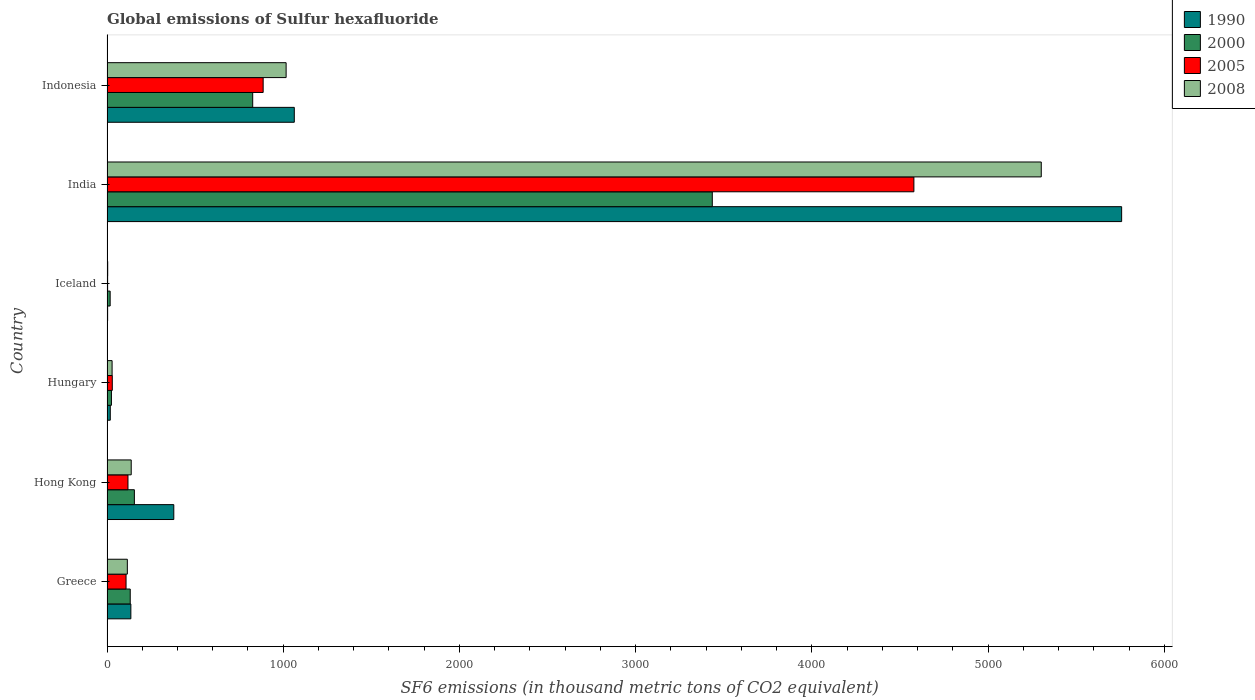How many groups of bars are there?
Offer a very short reply. 6. Are the number of bars per tick equal to the number of legend labels?
Make the answer very short. Yes. Are the number of bars on each tick of the Y-axis equal?
Offer a terse response. Yes. What is the label of the 5th group of bars from the top?
Give a very brief answer. Hong Kong. What is the global emissions of Sulfur hexafluoride in 2008 in Indonesia?
Offer a terse response. 1016.4. Across all countries, what is the maximum global emissions of Sulfur hexafluoride in 2005?
Offer a very short reply. 4578.7. What is the total global emissions of Sulfur hexafluoride in 2005 in the graph?
Your answer should be compact. 5725.4. What is the difference between the global emissions of Sulfur hexafluoride in 2008 in India and that in Indonesia?
Ensure brevity in your answer.  4285. What is the difference between the global emissions of Sulfur hexafluoride in 2008 in Greece and the global emissions of Sulfur hexafluoride in 1990 in Hong Kong?
Make the answer very short. -263.6. What is the average global emissions of Sulfur hexafluoride in 2005 per country?
Provide a short and direct response. 954.23. What is the difference between the global emissions of Sulfur hexafluoride in 1990 and global emissions of Sulfur hexafluoride in 2000 in Indonesia?
Your answer should be very brief. 236. In how many countries, is the global emissions of Sulfur hexafluoride in 2008 greater than 3200 thousand metric tons?
Provide a short and direct response. 1. What is the ratio of the global emissions of Sulfur hexafluoride in 2008 in Greece to that in Iceland?
Give a very brief answer. 28.85. What is the difference between the highest and the second highest global emissions of Sulfur hexafluoride in 2000?
Ensure brevity in your answer.  2607.9. What is the difference between the highest and the lowest global emissions of Sulfur hexafluoride in 2000?
Make the answer very short. 3416.8. In how many countries, is the global emissions of Sulfur hexafluoride in 2008 greater than the average global emissions of Sulfur hexafluoride in 2008 taken over all countries?
Your response must be concise. 1. Is the sum of the global emissions of Sulfur hexafluoride in 2008 in Iceland and India greater than the maximum global emissions of Sulfur hexafluoride in 2005 across all countries?
Make the answer very short. Yes. What does the 4th bar from the top in Hong Kong represents?
Provide a succinct answer. 1990. What does the 2nd bar from the bottom in Hungary represents?
Your answer should be very brief. 2000. Is it the case that in every country, the sum of the global emissions of Sulfur hexafluoride in 2008 and global emissions of Sulfur hexafluoride in 2000 is greater than the global emissions of Sulfur hexafluoride in 1990?
Your answer should be compact. No. Are all the bars in the graph horizontal?
Offer a terse response. Yes. What is the difference between two consecutive major ticks on the X-axis?
Make the answer very short. 1000. Where does the legend appear in the graph?
Your answer should be very brief. Top right. How are the legend labels stacked?
Keep it short and to the point. Vertical. What is the title of the graph?
Make the answer very short. Global emissions of Sulfur hexafluoride. What is the label or title of the X-axis?
Your response must be concise. SF6 emissions (in thousand metric tons of CO2 equivalent). What is the label or title of the Y-axis?
Your answer should be compact. Country. What is the SF6 emissions (in thousand metric tons of CO2 equivalent) of 1990 in Greece?
Offer a terse response. 135.4. What is the SF6 emissions (in thousand metric tons of CO2 equivalent) in 2000 in Greece?
Give a very brief answer. 131.8. What is the SF6 emissions (in thousand metric tons of CO2 equivalent) in 2005 in Greece?
Your answer should be very brief. 108.1. What is the SF6 emissions (in thousand metric tons of CO2 equivalent) of 2008 in Greece?
Ensure brevity in your answer.  115.4. What is the SF6 emissions (in thousand metric tons of CO2 equivalent) in 1990 in Hong Kong?
Offer a terse response. 379. What is the SF6 emissions (in thousand metric tons of CO2 equivalent) in 2000 in Hong Kong?
Offer a very short reply. 155.3. What is the SF6 emissions (in thousand metric tons of CO2 equivalent) in 2005 in Hong Kong?
Keep it short and to the point. 119. What is the SF6 emissions (in thousand metric tons of CO2 equivalent) of 2008 in Hong Kong?
Keep it short and to the point. 137.4. What is the SF6 emissions (in thousand metric tons of CO2 equivalent) in 1990 in Hungary?
Give a very brief answer. 18.6. What is the SF6 emissions (in thousand metric tons of CO2 equivalent) in 2000 in Hungary?
Your answer should be compact. 25.2. What is the SF6 emissions (in thousand metric tons of CO2 equivalent) in 2005 in Hungary?
Make the answer very short. 30. What is the SF6 emissions (in thousand metric tons of CO2 equivalent) in 2008 in Hungary?
Your response must be concise. 28.9. What is the SF6 emissions (in thousand metric tons of CO2 equivalent) in 1990 in Iceland?
Offer a terse response. 3.5. What is the SF6 emissions (in thousand metric tons of CO2 equivalent) in 1990 in India?
Your answer should be very brief. 5757.5. What is the SF6 emissions (in thousand metric tons of CO2 equivalent) of 2000 in India?
Provide a short and direct response. 3434.7. What is the SF6 emissions (in thousand metric tons of CO2 equivalent) in 2005 in India?
Your answer should be very brief. 4578.7. What is the SF6 emissions (in thousand metric tons of CO2 equivalent) of 2008 in India?
Provide a succinct answer. 5301.4. What is the SF6 emissions (in thousand metric tons of CO2 equivalent) in 1990 in Indonesia?
Offer a very short reply. 1062.8. What is the SF6 emissions (in thousand metric tons of CO2 equivalent) in 2000 in Indonesia?
Your answer should be compact. 826.8. What is the SF6 emissions (in thousand metric tons of CO2 equivalent) in 2005 in Indonesia?
Your answer should be very brief. 886.1. What is the SF6 emissions (in thousand metric tons of CO2 equivalent) in 2008 in Indonesia?
Offer a very short reply. 1016.4. Across all countries, what is the maximum SF6 emissions (in thousand metric tons of CO2 equivalent) of 1990?
Make the answer very short. 5757.5. Across all countries, what is the maximum SF6 emissions (in thousand metric tons of CO2 equivalent) in 2000?
Offer a very short reply. 3434.7. Across all countries, what is the maximum SF6 emissions (in thousand metric tons of CO2 equivalent) in 2005?
Provide a succinct answer. 4578.7. Across all countries, what is the maximum SF6 emissions (in thousand metric tons of CO2 equivalent) of 2008?
Your answer should be compact. 5301.4. Across all countries, what is the minimum SF6 emissions (in thousand metric tons of CO2 equivalent) of 2000?
Keep it short and to the point. 17.9. What is the total SF6 emissions (in thousand metric tons of CO2 equivalent) in 1990 in the graph?
Keep it short and to the point. 7356.8. What is the total SF6 emissions (in thousand metric tons of CO2 equivalent) in 2000 in the graph?
Ensure brevity in your answer.  4591.7. What is the total SF6 emissions (in thousand metric tons of CO2 equivalent) in 2005 in the graph?
Provide a succinct answer. 5725.4. What is the total SF6 emissions (in thousand metric tons of CO2 equivalent) of 2008 in the graph?
Your response must be concise. 6603.5. What is the difference between the SF6 emissions (in thousand metric tons of CO2 equivalent) of 1990 in Greece and that in Hong Kong?
Make the answer very short. -243.6. What is the difference between the SF6 emissions (in thousand metric tons of CO2 equivalent) in 2000 in Greece and that in Hong Kong?
Provide a succinct answer. -23.5. What is the difference between the SF6 emissions (in thousand metric tons of CO2 equivalent) of 1990 in Greece and that in Hungary?
Offer a very short reply. 116.8. What is the difference between the SF6 emissions (in thousand metric tons of CO2 equivalent) in 2000 in Greece and that in Hungary?
Provide a succinct answer. 106.6. What is the difference between the SF6 emissions (in thousand metric tons of CO2 equivalent) of 2005 in Greece and that in Hungary?
Provide a short and direct response. 78.1. What is the difference between the SF6 emissions (in thousand metric tons of CO2 equivalent) in 2008 in Greece and that in Hungary?
Provide a short and direct response. 86.5. What is the difference between the SF6 emissions (in thousand metric tons of CO2 equivalent) in 1990 in Greece and that in Iceland?
Offer a very short reply. 131.9. What is the difference between the SF6 emissions (in thousand metric tons of CO2 equivalent) in 2000 in Greece and that in Iceland?
Give a very brief answer. 113.9. What is the difference between the SF6 emissions (in thousand metric tons of CO2 equivalent) in 2005 in Greece and that in Iceland?
Make the answer very short. 104.6. What is the difference between the SF6 emissions (in thousand metric tons of CO2 equivalent) in 2008 in Greece and that in Iceland?
Make the answer very short. 111.4. What is the difference between the SF6 emissions (in thousand metric tons of CO2 equivalent) of 1990 in Greece and that in India?
Your answer should be very brief. -5622.1. What is the difference between the SF6 emissions (in thousand metric tons of CO2 equivalent) of 2000 in Greece and that in India?
Ensure brevity in your answer.  -3302.9. What is the difference between the SF6 emissions (in thousand metric tons of CO2 equivalent) in 2005 in Greece and that in India?
Your answer should be compact. -4470.6. What is the difference between the SF6 emissions (in thousand metric tons of CO2 equivalent) in 2008 in Greece and that in India?
Your response must be concise. -5186. What is the difference between the SF6 emissions (in thousand metric tons of CO2 equivalent) in 1990 in Greece and that in Indonesia?
Keep it short and to the point. -927.4. What is the difference between the SF6 emissions (in thousand metric tons of CO2 equivalent) in 2000 in Greece and that in Indonesia?
Your answer should be very brief. -695. What is the difference between the SF6 emissions (in thousand metric tons of CO2 equivalent) in 2005 in Greece and that in Indonesia?
Make the answer very short. -778. What is the difference between the SF6 emissions (in thousand metric tons of CO2 equivalent) of 2008 in Greece and that in Indonesia?
Provide a short and direct response. -901. What is the difference between the SF6 emissions (in thousand metric tons of CO2 equivalent) of 1990 in Hong Kong and that in Hungary?
Offer a very short reply. 360.4. What is the difference between the SF6 emissions (in thousand metric tons of CO2 equivalent) in 2000 in Hong Kong and that in Hungary?
Provide a succinct answer. 130.1. What is the difference between the SF6 emissions (in thousand metric tons of CO2 equivalent) in 2005 in Hong Kong and that in Hungary?
Ensure brevity in your answer.  89. What is the difference between the SF6 emissions (in thousand metric tons of CO2 equivalent) in 2008 in Hong Kong and that in Hungary?
Provide a succinct answer. 108.5. What is the difference between the SF6 emissions (in thousand metric tons of CO2 equivalent) of 1990 in Hong Kong and that in Iceland?
Provide a short and direct response. 375.5. What is the difference between the SF6 emissions (in thousand metric tons of CO2 equivalent) in 2000 in Hong Kong and that in Iceland?
Give a very brief answer. 137.4. What is the difference between the SF6 emissions (in thousand metric tons of CO2 equivalent) in 2005 in Hong Kong and that in Iceland?
Provide a succinct answer. 115.5. What is the difference between the SF6 emissions (in thousand metric tons of CO2 equivalent) of 2008 in Hong Kong and that in Iceland?
Ensure brevity in your answer.  133.4. What is the difference between the SF6 emissions (in thousand metric tons of CO2 equivalent) in 1990 in Hong Kong and that in India?
Keep it short and to the point. -5378.5. What is the difference between the SF6 emissions (in thousand metric tons of CO2 equivalent) of 2000 in Hong Kong and that in India?
Offer a very short reply. -3279.4. What is the difference between the SF6 emissions (in thousand metric tons of CO2 equivalent) of 2005 in Hong Kong and that in India?
Provide a succinct answer. -4459.7. What is the difference between the SF6 emissions (in thousand metric tons of CO2 equivalent) of 2008 in Hong Kong and that in India?
Your response must be concise. -5164. What is the difference between the SF6 emissions (in thousand metric tons of CO2 equivalent) of 1990 in Hong Kong and that in Indonesia?
Keep it short and to the point. -683.8. What is the difference between the SF6 emissions (in thousand metric tons of CO2 equivalent) of 2000 in Hong Kong and that in Indonesia?
Your response must be concise. -671.5. What is the difference between the SF6 emissions (in thousand metric tons of CO2 equivalent) of 2005 in Hong Kong and that in Indonesia?
Offer a terse response. -767.1. What is the difference between the SF6 emissions (in thousand metric tons of CO2 equivalent) of 2008 in Hong Kong and that in Indonesia?
Keep it short and to the point. -879. What is the difference between the SF6 emissions (in thousand metric tons of CO2 equivalent) in 1990 in Hungary and that in Iceland?
Provide a short and direct response. 15.1. What is the difference between the SF6 emissions (in thousand metric tons of CO2 equivalent) in 2008 in Hungary and that in Iceland?
Provide a succinct answer. 24.9. What is the difference between the SF6 emissions (in thousand metric tons of CO2 equivalent) of 1990 in Hungary and that in India?
Make the answer very short. -5738.9. What is the difference between the SF6 emissions (in thousand metric tons of CO2 equivalent) of 2000 in Hungary and that in India?
Your response must be concise. -3409.5. What is the difference between the SF6 emissions (in thousand metric tons of CO2 equivalent) of 2005 in Hungary and that in India?
Offer a terse response. -4548.7. What is the difference between the SF6 emissions (in thousand metric tons of CO2 equivalent) of 2008 in Hungary and that in India?
Keep it short and to the point. -5272.5. What is the difference between the SF6 emissions (in thousand metric tons of CO2 equivalent) of 1990 in Hungary and that in Indonesia?
Your response must be concise. -1044.2. What is the difference between the SF6 emissions (in thousand metric tons of CO2 equivalent) in 2000 in Hungary and that in Indonesia?
Keep it short and to the point. -801.6. What is the difference between the SF6 emissions (in thousand metric tons of CO2 equivalent) of 2005 in Hungary and that in Indonesia?
Your response must be concise. -856.1. What is the difference between the SF6 emissions (in thousand metric tons of CO2 equivalent) of 2008 in Hungary and that in Indonesia?
Your response must be concise. -987.5. What is the difference between the SF6 emissions (in thousand metric tons of CO2 equivalent) of 1990 in Iceland and that in India?
Your response must be concise. -5754. What is the difference between the SF6 emissions (in thousand metric tons of CO2 equivalent) in 2000 in Iceland and that in India?
Your answer should be compact. -3416.8. What is the difference between the SF6 emissions (in thousand metric tons of CO2 equivalent) in 2005 in Iceland and that in India?
Give a very brief answer. -4575.2. What is the difference between the SF6 emissions (in thousand metric tons of CO2 equivalent) of 2008 in Iceland and that in India?
Offer a terse response. -5297.4. What is the difference between the SF6 emissions (in thousand metric tons of CO2 equivalent) of 1990 in Iceland and that in Indonesia?
Your answer should be compact. -1059.3. What is the difference between the SF6 emissions (in thousand metric tons of CO2 equivalent) of 2000 in Iceland and that in Indonesia?
Provide a succinct answer. -808.9. What is the difference between the SF6 emissions (in thousand metric tons of CO2 equivalent) of 2005 in Iceland and that in Indonesia?
Your answer should be very brief. -882.6. What is the difference between the SF6 emissions (in thousand metric tons of CO2 equivalent) of 2008 in Iceland and that in Indonesia?
Offer a terse response. -1012.4. What is the difference between the SF6 emissions (in thousand metric tons of CO2 equivalent) of 1990 in India and that in Indonesia?
Ensure brevity in your answer.  4694.7. What is the difference between the SF6 emissions (in thousand metric tons of CO2 equivalent) of 2000 in India and that in Indonesia?
Make the answer very short. 2607.9. What is the difference between the SF6 emissions (in thousand metric tons of CO2 equivalent) of 2005 in India and that in Indonesia?
Offer a very short reply. 3692.6. What is the difference between the SF6 emissions (in thousand metric tons of CO2 equivalent) in 2008 in India and that in Indonesia?
Give a very brief answer. 4285. What is the difference between the SF6 emissions (in thousand metric tons of CO2 equivalent) of 1990 in Greece and the SF6 emissions (in thousand metric tons of CO2 equivalent) of 2000 in Hong Kong?
Provide a short and direct response. -19.9. What is the difference between the SF6 emissions (in thousand metric tons of CO2 equivalent) of 2005 in Greece and the SF6 emissions (in thousand metric tons of CO2 equivalent) of 2008 in Hong Kong?
Give a very brief answer. -29.3. What is the difference between the SF6 emissions (in thousand metric tons of CO2 equivalent) of 1990 in Greece and the SF6 emissions (in thousand metric tons of CO2 equivalent) of 2000 in Hungary?
Provide a succinct answer. 110.2. What is the difference between the SF6 emissions (in thousand metric tons of CO2 equivalent) in 1990 in Greece and the SF6 emissions (in thousand metric tons of CO2 equivalent) in 2005 in Hungary?
Provide a succinct answer. 105.4. What is the difference between the SF6 emissions (in thousand metric tons of CO2 equivalent) of 1990 in Greece and the SF6 emissions (in thousand metric tons of CO2 equivalent) of 2008 in Hungary?
Your answer should be very brief. 106.5. What is the difference between the SF6 emissions (in thousand metric tons of CO2 equivalent) in 2000 in Greece and the SF6 emissions (in thousand metric tons of CO2 equivalent) in 2005 in Hungary?
Offer a terse response. 101.8. What is the difference between the SF6 emissions (in thousand metric tons of CO2 equivalent) in 2000 in Greece and the SF6 emissions (in thousand metric tons of CO2 equivalent) in 2008 in Hungary?
Offer a terse response. 102.9. What is the difference between the SF6 emissions (in thousand metric tons of CO2 equivalent) of 2005 in Greece and the SF6 emissions (in thousand metric tons of CO2 equivalent) of 2008 in Hungary?
Provide a succinct answer. 79.2. What is the difference between the SF6 emissions (in thousand metric tons of CO2 equivalent) of 1990 in Greece and the SF6 emissions (in thousand metric tons of CO2 equivalent) of 2000 in Iceland?
Your response must be concise. 117.5. What is the difference between the SF6 emissions (in thousand metric tons of CO2 equivalent) of 1990 in Greece and the SF6 emissions (in thousand metric tons of CO2 equivalent) of 2005 in Iceland?
Ensure brevity in your answer.  131.9. What is the difference between the SF6 emissions (in thousand metric tons of CO2 equivalent) of 1990 in Greece and the SF6 emissions (in thousand metric tons of CO2 equivalent) of 2008 in Iceland?
Your answer should be very brief. 131.4. What is the difference between the SF6 emissions (in thousand metric tons of CO2 equivalent) in 2000 in Greece and the SF6 emissions (in thousand metric tons of CO2 equivalent) in 2005 in Iceland?
Provide a succinct answer. 128.3. What is the difference between the SF6 emissions (in thousand metric tons of CO2 equivalent) of 2000 in Greece and the SF6 emissions (in thousand metric tons of CO2 equivalent) of 2008 in Iceland?
Make the answer very short. 127.8. What is the difference between the SF6 emissions (in thousand metric tons of CO2 equivalent) of 2005 in Greece and the SF6 emissions (in thousand metric tons of CO2 equivalent) of 2008 in Iceland?
Provide a short and direct response. 104.1. What is the difference between the SF6 emissions (in thousand metric tons of CO2 equivalent) of 1990 in Greece and the SF6 emissions (in thousand metric tons of CO2 equivalent) of 2000 in India?
Your answer should be compact. -3299.3. What is the difference between the SF6 emissions (in thousand metric tons of CO2 equivalent) in 1990 in Greece and the SF6 emissions (in thousand metric tons of CO2 equivalent) in 2005 in India?
Offer a very short reply. -4443.3. What is the difference between the SF6 emissions (in thousand metric tons of CO2 equivalent) of 1990 in Greece and the SF6 emissions (in thousand metric tons of CO2 equivalent) of 2008 in India?
Your answer should be compact. -5166. What is the difference between the SF6 emissions (in thousand metric tons of CO2 equivalent) in 2000 in Greece and the SF6 emissions (in thousand metric tons of CO2 equivalent) in 2005 in India?
Offer a terse response. -4446.9. What is the difference between the SF6 emissions (in thousand metric tons of CO2 equivalent) in 2000 in Greece and the SF6 emissions (in thousand metric tons of CO2 equivalent) in 2008 in India?
Your response must be concise. -5169.6. What is the difference between the SF6 emissions (in thousand metric tons of CO2 equivalent) in 2005 in Greece and the SF6 emissions (in thousand metric tons of CO2 equivalent) in 2008 in India?
Make the answer very short. -5193.3. What is the difference between the SF6 emissions (in thousand metric tons of CO2 equivalent) of 1990 in Greece and the SF6 emissions (in thousand metric tons of CO2 equivalent) of 2000 in Indonesia?
Provide a succinct answer. -691.4. What is the difference between the SF6 emissions (in thousand metric tons of CO2 equivalent) in 1990 in Greece and the SF6 emissions (in thousand metric tons of CO2 equivalent) in 2005 in Indonesia?
Your answer should be compact. -750.7. What is the difference between the SF6 emissions (in thousand metric tons of CO2 equivalent) of 1990 in Greece and the SF6 emissions (in thousand metric tons of CO2 equivalent) of 2008 in Indonesia?
Offer a terse response. -881. What is the difference between the SF6 emissions (in thousand metric tons of CO2 equivalent) in 2000 in Greece and the SF6 emissions (in thousand metric tons of CO2 equivalent) in 2005 in Indonesia?
Provide a succinct answer. -754.3. What is the difference between the SF6 emissions (in thousand metric tons of CO2 equivalent) in 2000 in Greece and the SF6 emissions (in thousand metric tons of CO2 equivalent) in 2008 in Indonesia?
Make the answer very short. -884.6. What is the difference between the SF6 emissions (in thousand metric tons of CO2 equivalent) in 2005 in Greece and the SF6 emissions (in thousand metric tons of CO2 equivalent) in 2008 in Indonesia?
Offer a terse response. -908.3. What is the difference between the SF6 emissions (in thousand metric tons of CO2 equivalent) of 1990 in Hong Kong and the SF6 emissions (in thousand metric tons of CO2 equivalent) of 2000 in Hungary?
Provide a short and direct response. 353.8. What is the difference between the SF6 emissions (in thousand metric tons of CO2 equivalent) in 1990 in Hong Kong and the SF6 emissions (in thousand metric tons of CO2 equivalent) in 2005 in Hungary?
Provide a short and direct response. 349. What is the difference between the SF6 emissions (in thousand metric tons of CO2 equivalent) of 1990 in Hong Kong and the SF6 emissions (in thousand metric tons of CO2 equivalent) of 2008 in Hungary?
Your answer should be compact. 350.1. What is the difference between the SF6 emissions (in thousand metric tons of CO2 equivalent) of 2000 in Hong Kong and the SF6 emissions (in thousand metric tons of CO2 equivalent) of 2005 in Hungary?
Provide a short and direct response. 125.3. What is the difference between the SF6 emissions (in thousand metric tons of CO2 equivalent) in 2000 in Hong Kong and the SF6 emissions (in thousand metric tons of CO2 equivalent) in 2008 in Hungary?
Keep it short and to the point. 126.4. What is the difference between the SF6 emissions (in thousand metric tons of CO2 equivalent) of 2005 in Hong Kong and the SF6 emissions (in thousand metric tons of CO2 equivalent) of 2008 in Hungary?
Make the answer very short. 90.1. What is the difference between the SF6 emissions (in thousand metric tons of CO2 equivalent) in 1990 in Hong Kong and the SF6 emissions (in thousand metric tons of CO2 equivalent) in 2000 in Iceland?
Offer a very short reply. 361.1. What is the difference between the SF6 emissions (in thousand metric tons of CO2 equivalent) in 1990 in Hong Kong and the SF6 emissions (in thousand metric tons of CO2 equivalent) in 2005 in Iceland?
Your response must be concise. 375.5. What is the difference between the SF6 emissions (in thousand metric tons of CO2 equivalent) in 1990 in Hong Kong and the SF6 emissions (in thousand metric tons of CO2 equivalent) in 2008 in Iceland?
Offer a very short reply. 375. What is the difference between the SF6 emissions (in thousand metric tons of CO2 equivalent) of 2000 in Hong Kong and the SF6 emissions (in thousand metric tons of CO2 equivalent) of 2005 in Iceland?
Give a very brief answer. 151.8. What is the difference between the SF6 emissions (in thousand metric tons of CO2 equivalent) of 2000 in Hong Kong and the SF6 emissions (in thousand metric tons of CO2 equivalent) of 2008 in Iceland?
Your answer should be compact. 151.3. What is the difference between the SF6 emissions (in thousand metric tons of CO2 equivalent) of 2005 in Hong Kong and the SF6 emissions (in thousand metric tons of CO2 equivalent) of 2008 in Iceland?
Give a very brief answer. 115. What is the difference between the SF6 emissions (in thousand metric tons of CO2 equivalent) in 1990 in Hong Kong and the SF6 emissions (in thousand metric tons of CO2 equivalent) in 2000 in India?
Keep it short and to the point. -3055.7. What is the difference between the SF6 emissions (in thousand metric tons of CO2 equivalent) in 1990 in Hong Kong and the SF6 emissions (in thousand metric tons of CO2 equivalent) in 2005 in India?
Give a very brief answer. -4199.7. What is the difference between the SF6 emissions (in thousand metric tons of CO2 equivalent) in 1990 in Hong Kong and the SF6 emissions (in thousand metric tons of CO2 equivalent) in 2008 in India?
Give a very brief answer. -4922.4. What is the difference between the SF6 emissions (in thousand metric tons of CO2 equivalent) in 2000 in Hong Kong and the SF6 emissions (in thousand metric tons of CO2 equivalent) in 2005 in India?
Give a very brief answer. -4423.4. What is the difference between the SF6 emissions (in thousand metric tons of CO2 equivalent) of 2000 in Hong Kong and the SF6 emissions (in thousand metric tons of CO2 equivalent) of 2008 in India?
Your answer should be compact. -5146.1. What is the difference between the SF6 emissions (in thousand metric tons of CO2 equivalent) of 2005 in Hong Kong and the SF6 emissions (in thousand metric tons of CO2 equivalent) of 2008 in India?
Your answer should be very brief. -5182.4. What is the difference between the SF6 emissions (in thousand metric tons of CO2 equivalent) of 1990 in Hong Kong and the SF6 emissions (in thousand metric tons of CO2 equivalent) of 2000 in Indonesia?
Make the answer very short. -447.8. What is the difference between the SF6 emissions (in thousand metric tons of CO2 equivalent) of 1990 in Hong Kong and the SF6 emissions (in thousand metric tons of CO2 equivalent) of 2005 in Indonesia?
Offer a terse response. -507.1. What is the difference between the SF6 emissions (in thousand metric tons of CO2 equivalent) of 1990 in Hong Kong and the SF6 emissions (in thousand metric tons of CO2 equivalent) of 2008 in Indonesia?
Keep it short and to the point. -637.4. What is the difference between the SF6 emissions (in thousand metric tons of CO2 equivalent) of 2000 in Hong Kong and the SF6 emissions (in thousand metric tons of CO2 equivalent) of 2005 in Indonesia?
Make the answer very short. -730.8. What is the difference between the SF6 emissions (in thousand metric tons of CO2 equivalent) of 2000 in Hong Kong and the SF6 emissions (in thousand metric tons of CO2 equivalent) of 2008 in Indonesia?
Offer a very short reply. -861.1. What is the difference between the SF6 emissions (in thousand metric tons of CO2 equivalent) of 2005 in Hong Kong and the SF6 emissions (in thousand metric tons of CO2 equivalent) of 2008 in Indonesia?
Keep it short and to the point. -897.4. What is the difference between the SF6 emissions (in thousand metric tons of CO2 equivalent) of 1990 in Hungary and the SF6 emissions (in thousand metric tons of CO2 equivalent) of 2005 in Iceland?
Your response must be concise. 15.1. What is the difference between the SF6 emissions (in thousand metric tons of CO2 equivalent) in 2000 in Hungary and the SF6 emissions (in thousand metric tons of CO2 equivalent) in 2005 in Iceland?
Your response must be concise. 21.7. What is the difference between the SF6 emissions (in thousand metric tons of CO2 equivalent) in 2000 in Hungary and the SF6 emissions (in thousand metric tons of CO2 equivalent) in 2008 in Iceland?
Ensure brevity in your answer.  21.2. What is the difference between the SF6 emissions (in thousand metric tons of CO2 equivalent) of 1990 in Hungary and the SF6 emissions (in thousand metric tons of CO2 equivalent) of 2000 in India?
Offer a terse response. -3416.1. What is the difference between the SF6 emissions (in thousand metric tons of CO2 equivalent) in 1990 in Hungary and the SF6 emissions (in thousand metric tons of CO2 equivalent) in 2005 in India?
Offer a terse response. -4560.1. What is the difference between the SF6 emissions (in thousand metric tons of CO2 equivalent) of 1990 in Hungary and the SF6 emissions (in thousand metric tons of CO2 equivalent) of 2008 in India?
Keep it short and to the point. -5282.8. What is the difference between the SF6 emissions (in thousand metric tons of CO2 equivalent) of 2000 in Hungary and the SF6 emissions (in thousand metric tons of CO2 equivalent) of 2005 in India?
Offer a very short reply. -4553.5. What is the difference between the SF6 emissions (in thousand metric tons of CO2 equivalent) of 2000 in Hungary and the SF6 emissions (in thousand metric tons of CO2 equivalent) of 2008 in India?
Offer a terse response. -5276.2. What is the difference between the SF6 emissions (in thousand metric tons of CO2 equivalent) in 2005 in Hungary and the SF6 emissions (in thousand metric tons of CO2 equivalent) in 2008 in India?
Make the answer very short. -5271.4. What is the difference between the SF6 emissions (in thousand metric tons of CO2 equivalent) of 1990 in Hungary and the SF6 emissions (in thousand metric tons of CO2 equivalent) of 2000 in Indonesia?
Your response must be concise. -808.2. What is the difference between the SF6 emissions (in thousand metric tons of CO2 equivalent) of 1990 in Hungary and the SF6 emissions (in thousand metric tons of CO2 equivalent) of 2005 in Indonesia?
Keep it short and to the point. -867.5. What is the difference between the SF6 emissions (in thousand metric tons of CO2 equivalent) of 1990 in Hungary and the SF6 emissions (in thousand metric tons of CO2 equivalent) of 2008 in Indonesia?
Provide a short and direct response. -997.8. What is the difference between the SF6 emissions (in thousand metric tons of CO2 equivalent) of 2000 in Hungary and the SF6 emissions (in thousand metric tons of CO2 equivalent) of 2005 in Indonesia?
Keep it short and to the point. -860.9. What is the difference between the SF6 emissions (in thousand metric tons of CO2 equivalent) in 2000 in Hungary and the SF6 emissions (in thousand metric tons of CO2 equivalent) in 2008 in Indonesia?
Your answer should be very brief. -991.2. What is the difference between the SF6 emissions (in thousand metric tons of CO2 equivalent) in 2005 in Hungary and the SF6 emissions (in thousand metric tons of CO2 equivalent) in 2008 in Indonesia?
Give a very brief answer. -986.4. What is the difference between the SF6 emissions (in thousand metric tons of CO2 equivalent) of 1990 in Iceland and the SF6 emissions (in thousand metric tons of CO2 equivalent) of 2000 in India?
Provide a short and direct response. -3431.2. What is the difference between the SF6 emissions (in thousand metric tons of CO2 equivalent) in 1990 in Iceland and the SF6 emissions (in thousand metric tons of CO2 equivalent) in 2005 in India?
Your response must be concise. -4575.2. What is the difference between the SF6 emissions (in thousand metric tons of CO2 equivalent) in 1990 in Iceland and the SF6 emissions (in thousand metric tons of CO2 equivalent) in 2008 in India?
Provide a succinct answer. -5297.9. What is the difference between the SF6 emissions (in thousand metric tons of CO2 equivalent) in 2000 in Iceland and the SF6 emissions (in thousand metric tons of CO2 equivalent) in 2005 in India?
Offer a very short reply. -4560.8. What is the difference between the SF6 emissions (in thousand metric tons of CO2 equivalent) in 2000 in Iceland and the SF6 emissions (in thousand metric tons of CO2 equivalent) in 2008 in India?
Your response must be concise. -5283.5. What is the difference between the SF6 emissions (in thousand metric tons of CO2 equivalent) of 2005 in Iceland and the SF6 emissions (in thousand metric tons of CO2 equivalent) of 2008 in India?
Ensure brevity in your answer.  -5297.9. What is the difference between the SF6 emissions (in thousand metric tons of CO2 equivalent) of 1990 in Iceland and the SF6 emissions (in thousand metric tons of CO2 equivalent) of 2000 in Indonesia?
Make the answer very short. -823.3. What is the difference between the SF6 emissions (in thousand metric tons of CO2 equivalent) of 1990 in Iceland and the SF6 emissions (in thousand metric tons of CO2 equivalent) of 2005 in Indonesia?
Your answer should be very brief. -882.6. What is the difference between the SF6 emissions (in thousand metric tons of CO2 equivalent) of 1990 in Iceland and the SF6 emissions (in thousand metric tons of CO2 equivalent) of 2008 in Indonesia?
Keep it short and to the point. -1012.9. What is the difference between the SF6 emissions (in thousand metric tons of CO2 equivalent) in 2000 in Iceland and the SF6 emissions (in thousand metric tons of CO2 equivalent) in 2005 in Indonesia?
Keep it short and to the point. -868.2. What is the difference between the SF6 emissions (in thousand metric tons of CO2 equivalent) of 2000 in Iceland and the SF6 emissions (in thousand metric tons of CO2 equivalent) of 2008 in Indonesia?
Offer a terse response. -998.5. What is the difference between the SF6 emissions (in thousand metric tons of CO2 equivalent) in 2005 in Iceland and the SF6 emissions (in thousand metric tons of CO2 equivalent) in 2008 in Indonesia?
Keep it short and to the point. -1012.9. What is the difference between the SF6 emissions (in thousand metric tons of CO2 equivalent) in 1990 in India and the SF6 emissions (in thousand metric tons of CO2 equivalent) in 2000 in Indonesia?
Give a very brief answer. 4930.7. What is the difference between the SF6 emissions (in thousand metric tons of CO2 equivalent) in 1990 in India and the SF6 emissions (in thousand metric tons of CO2 equivalent) in 2005 in Indonesia?
Offer a terse response. 4871.4. What is the difference between the SF6 emissions (in thousand metric tons of CO2 equivalent) in 1990 in India and the SF6 emissions (in thousand metric tons of CO2 equivalent) in 2008 in Indonesia?
Give a very brief answer. 4741.1. What is the difference between the SF6 emissions (in thousand metric tons of CO2 equivalent) in 2000 in India and the SF6 emissions (in thousand metric tons of CO2 equivalent) in 2005 in Indonesia?
Offer a terse response. 2548.6. What is the difference between the SF6 emissions (in thousand metric tons of CO2 equivalent) of 2000 in India and the SF6 emissions (in thousand metric tons of CO2 equivalent) of 2008 in Indonesia?
Your response must be concise. 2418.3. What is the difference between the SF6 emissions (in thousand metric tons of CO2 equivalent) in 2005 in India and the SF6 emissions (in thousand metric tons of CO2 equivalent) in 2008 in Indonesia?
Ensure brevity in your answer.  3562.3. What is the average SF6 emissions (in thousand metric tons of CO2 equivalent) of 1990 per country?
Offer a very short reply. 1226.13. What is the average SF6 emissions (in thousand metric tons of CO2 equivalent) in 2000 per country?
Your answer should be compact. 765.28. What is the average SF6 emissions (in thousand metric tons of CO2 equivalent) of 2005 per country?
Offer a terse response. 954.23. What is the average SF6 emissions (in thousand metric tons of CO2 equivalent) in 2008 per country?
Your answer should be very brief. 1100.58. What is the difference between the SF6 emissions (in thousand metric tons of CO2 equivalent) in 1990 and SF6 emissions (in thousand metric tons of CO2 equivalent) in 2005 in Greece?
Offer a very short reply. 27.3. What is the difference between the SF6 emissions (in thousand metric tons of CO2 equivalent) in 1990 and SF6 emissions (in thousand metric tons of CO2 equivalent) in 2008 in Greece?
Provide a succinct answer. 20. What is the difference between the SF6 emissions (in thousand metric tons of CO2 equivalent) in 2000 and SF6 emissions (in thousand metric tons of CO2 equivalent) in 2005 in Greece?
Keep it short and to the point. 23.7. What is the difference between the SF6 emissions (in thousand metric tons of CO2 equivalent) in 2005 and SF6 emissions (in thousand metric tons of CO2 equivalent) in 2008 in Greece?
Make the answer very short. -7.3. What is the difference between the SF6 emissions (in thousand metric tons of CO2 equivalent) of 1990 and SF6 emissions (in thousand metric tons of CO2 equivalent) of 2000 in Hong Kong?
Provide a short and direct response. 223.7. What is the difference between the SF6 emissions (in thousand metric tons of CO2 equivalent) in 1990 and SF6 emissions (in thousand metric tons of CO2 equivalent) in 2005 in Hong Kong?
Provide a succinct answer. 260. What is the difference between the SF6 emissions (in thousand metric tons of CO2 equivalent) in 1990 and SF6 emissions (in thousand metric tons of CO2 equivalent) in 2008 in Hong Kong?
Provide a short and direct response. 241.6. What is the difference between the SF6 emissions (in thousand metric tons of CO2 equivalent) in 2000 and SF6 emissions (in thousand metric tons of CO2 equivalent) in 2005 in Hong Kong?
Your answer should be very brief. 36.3. What is the difference between the SF6 emissions (in thousand metric tons of CO2 equivalent) of 2000 and SF6 emissions (in thousand metric tons of CO2 equivalent) of 2008 in Hong Kong?
Your answer should be compact. 17.9. What is the difference between the SF6 emissions (in thousand metric tons of CO2 equivalent) in 2005 and SF6 emissions (in thousand metric tons of CO2 equivalent) in 2008 in Hong Kong?
Provide a succinct answer. -18.4. What is the difference between the SF6 emissions (in thousand metric tons of CO2 equivalent) in 2000 and SF6 emissions (in thousand metric tons of CO2 equivalent) in 2005 in Hungary?
Your response must be concise. -4.8. What is the difference between the SF6 emissions (in thousand metric tons of CO2 equivalent) in 2000 and SF6 emissions (in thousand metric tons of CO2 equivalent) in 2008 in Hungary?
Your answer should be very brief. -3.7. What is the difference between the SF6 emissions (in thousand metric tons of CO2 equivalent) of 2005 and SF6 emissions (in thousand metric tons of CO2 equivalent) of 2008 in Hungary?
Your response must be concise. 1.1. What is the difference between the SF6 emissions (in thousand metric tons of CO2 equivalent) in 1990 and SF6 emissions (in thousand metric tons of CO2 equivalent) in 2000 in Iceland?
Offer a terse response. -14.4. What is the difference between the SF6 emissions (in thousand metric tons of CO2 equivalent) of 1990 and SF6 emissions (in thousand metric tons of CO2 equivalent) of 2005 in Iceland?
Your answer should be compact. 0. What is the difference between the SF6 emissions (in thousand metric tons of CO2 equivalent) in 2005 and SF6 emissions (in thousand metric tons of CO2 equivalent) in 2008 in Iceland?
Ensure brevity in your answer.  -0.5. What is the difference between the SF6 emissions (in thousand metric tons of CO2 equivalent) of 1990 and SF6 emissions (in thousand metric tons of CO2 equivalent) of 2000 in India?
Your answer should be compact. 2322.8. What is the difference between the SF6 emissions (in thousand metric tons of CO2 equivalent) of 1990 and SF6 emissions (in thousand metric tons of CO2 equivalent) of 2005 in India?
Your response must be concise. 1178.8. What is the difference between the SF6 emissions (in thousand metric tons of CO2 equivalent) of 1990 and SF6 emissions (in thousand metric tons of CO2 equivalent) of 2008 in India?
Provide a succinct answer. 456.1. What is the difference between the SF6 emissions (in thousand metric tons of CO2 equivalent) in 2000 and SF6 emissions (in thousand metric tons of CO2 equivalent) in 2005 in India?
Offer a terse response. -1144. What is the difference between the SF6 emissions (in thousand metric tons of CO2 equivalent) in 2000 and SF6 emissions (in thousand metric tons of CO2 equivalent) in 2008 in India?
Make the answer very short. -1866.7. What is the difference between the SF6 emissions (in thousand metric tons of CO2 equivalent) in 2005 and SF6 emissions (in thousand metric tons of CO2 equivalent) in 2008 in India?
Provide a succinct answer. -722.7. What is the difference between the SF6 emissions (in thousand metric tons of CO2 equivalent) of 1990 and SF6 emissions (in thousand metric tons of CO2 equivalent) of 2000 in Indonesia?
Make the answer very short. 236. What is the difference between the SF6 emissions (in thousand metric tons of CO2 equivalent) of 1990 and SF6 emissions (in thousand metric tons of CO2 equivalent) of 2005 in Indonesia?
Keep it short and to the point. 176.7. What is the difference between the SF6 emissions (in thousand metric tons of CO2 equivalent) in 1990 and SF6 emissions (in thousand metric tons of CO2 equivalent) in 2008 in Indonesia?
Make the answer very short. 46.4. What is the difference between the SF6 emissions (in thousand metric tons of CO2 equivalent) of 2000 and SF6 emissions (in thousand metric tons of CO2 equivalent) of 2005 in Indonesia?
Offer a very short reply. -59.3. What is the difference between the SF6 emissions (in thousand metric tons of CO2 equivalent) in 2000 and SF6 emissions (in thousand metric tons of CO2 equivalent) in 2008 in Indonesia?
Your response must be concise. -189.6. What is the difference between the SF6 emissions (in thousand metric tons of CO2 equivalent) of 2005 and SF6 emissions (in thousand metric tons of CO2 equivalent) of 2008 in Indonesia?
Your response must be concise. -130.3. What is the ratio of the SF6 emissions (in thousand metric tons of CO2 equivalent) in 1990 in Greece to that in Hong Kong?
Offer a terse response. 0.36. What is the ratio of the SF6 emissions (in thousand metric tons of CO2 equivalent) of 2000 in Greece to that in Hong Kong?
Offer a very short reply. 0.85. What is the ratio of the SF6 emissions (in thousand metric tons of CO2 equivalent) of 2005 in Greece to that in Hong Kong?
Offer a terse response. 0.91. What is the ratio of the SF6 emissions (in thousand metric tons of CO2 equivalent) of 2008 in Greece to that in Hong Kong?
Provide a succinct answer. 0.84. What is the ratio of the SF6 emissions (in thousand metric tons of CO2 equivalent) in 1990 in Greece to that in Hungary?
Provide a short and direct response. 7.28. What is the ratio of the SF6 emissions (in thousand metric tons of CO2 equivalent) of 2000 in Greece to that in Hungary?
Offer a terse response. 5.23. What is the ratio of the SF6 emissions (in thousand metric tons of CO2 equivalent) of 2005 in Greece to that in Hungary?
Offer a very short reply. 3.6. What is the ratio of the SF6 emissions (in thousand metric tons of CO2 equivalent) in 2008 in Greece to that in Hungary?
Provide a short and direct response. 3.99. What is the ratio of the SF6 emissions (in thousand metric tons of CO2 equivalent) in 1990 in Greece to that in Iceland?
Make the answer very short. 38.69. What is the ratio of the SF6 emissions (in thousand metric tons of CO2 equivalent) of 2000 in Greece to that in Iceland?
Offer a terse response. 7.36. What is the ratio of the SF6 emissions (in thousand metric tons of CO2 equivalent) of 2005 in Greece to that in Iceland?
Offer a very short reply. 30.89. What is the ratio of the SF6 emissions (in thousand metric tons of CO2 equivalent) in 2008 in Greece to that in Iceland?
Offer a very short reply. 28.85. What is the ratio of the SF6 emissions (in thousand metric tons of CO2 equivalent) in 1990 in Greece to that in India?
Give a very brief answer. 0.02. What is the ratio of the SF6 emissions (in thousand metric tons of CO2 equivalent) of 2000 in Greece to that in India?
Provide a succinct answer. 0.04. What is the ratio of the SF6 emissions (in thousand metric tons of CO2 equivalent) in 2005 in Greece to that in India?
Offer a terse response. 0.02. What is the ratio of the SF6 emissions (in thousand metric tons of CO2 equivalent) of 2008 in Greece to that in India?
Make the answer very short. 0.02. What is the ratio of the SF6 emissions (in thousand metric tons of CO2 equivalent) in 1990 in Greece to that in Indonesia?
Make the answer very short. 0.13. What is the ratio of the SF6 emissions (in thousand metric tons of CO2 equivalent) of 2000 in Greece to that in Indonesia?
Make the answer very short. 0.16. What is the ratio of the SF6 emissions (in thousand metric tons of CO2 equivalent) of 2005 in Greece to that in Indonesia?
Make the answer very short. 0.12. What is the ratio of the SF6 emissions (in thousand metric tons of CO2 equivalent) of 2008 in Greece to that in Indonesia?
Make the answer very short. 0.11. What is the ratio of the SF6 emissions (in thousand metric tons of CO2 equivalent) in 1990 in Hong Kong to that in Hungary?
Offer a terse response. 20.38. What is the ratio of the SF6 emissions (in thousand metric tons of CO2 equivalent) in 2000 in Hong Kong to that in Hungary?
Offer a terse response. 6.16. What is the ratio of the SF6 emissions (in thousand metric tons of CO2 equivalent) of 2005 in Hong Kong to that in Hungary?
Keep it short and to the point. 3.97. What is the ratio of the SF6 emissions (in thousand metric tons of CO2 equivalent) of 2008 in Hong Kong to that in Hungary?
Your answer should be compact. 4.75. What is the ratio of the SF6 emissions (in thousand metric tons of CO2 equivalent) in 1990 in Hong Kong to that in Iceland?
Ensure brevity in your answer.  108.29. What is the ratio of the SF6 emissions (in thousand metric tons of CO2 equivalent) in 2000 in Hong Kong to that in Iceland?
Keep it short and to the point. 8.68. What is the ratio of the SF6 emissions (in thousand metric tons of CO2 equivalent) in 2005 in Hong Kong to that in Iceland?
Offer a very short reply. 34. What is the ratio of the SF6 emissions (in thousand metric tons of CO2 equivalent) of 2008 in Hong Kong to that in Iceland?
Your response must be concise. 34.35. What is the ratio of the SF6 emissions (in thousand metric tons of CO2 equivalent) of 1990 in Hong Kong to that in India?
Your answer should be very brief. 0.07. What is the ratio of the SF6 emissions (in thousand metric tons of CO2 equivalent) in 2000 in Hong Kong to that in India?
Make the answer very short. 0.05. What is the ratio of the SF6 emissions (in thousand metric tons of CO2 equivalent) of 2005 in Hong Kong to that in India?
Provide a succinct answer. 0.03. What is the ratio of the SF6 emissions (in thousand metric tons of CO2 equivalent) of 2008 in Hong Kong to that in India?
Offer a very short reply. 0.03. What is the ratio of the SF6 emissions (in thousand metric tons of CO2 equivalent) in 1990 in Hong Kong to that in Indonesia?
Make the answer very short. 0.36. What is the ratio of the SF6 emissions (in thousand metric tons of CO2 equivalent) in 2000 in Hong Kong to that in Indonesia?
Your answer should be compact. 0.19. What is the ratio of the SF6 emissions (in thousand metric tons of CO2 equivalent) in 2005 in Hong Kong to that in Indonesia?
Offer a terse response. 0.13. What is the ratio of the SF6 emissions (in thousand metric tons of CO2 equivalent) in 2008 in Hong Kong to that in Indonesia?
Offer a very short reply. 0.14. What is the ratio of the SF6 emissions (in thousand metric tons of CO2 equivalent) of 1990 in Hungary to that in Iceland?
Give a very brief answer. 5.31. What is the ratio of the SF6 emissions (in thousand metric tons of CO2 equivalent) of 2000 in Hungary to that in Iceland?
Your answer should be compact. 1.41. What is the ratio of the SF6 emissions (in thousand metric tons of CO2 equivalent) in 2005 in Hungary to that in Iceland?
Offer a terse response. 8.57. What is the ratio of the SF6 emissions (in thousand metric tons of CO2 equivalent) of 2008 in Hungary to that in Iceland?
Offer a very short reply. 7.22. What is the ratio of the SF6 emissions (in thousand metric tons of CO2 equivalent) of 1990 in Hungary to that in India?
Offer a terse response. 0. What is the ratio of the SF6 emissions (in thousand metric tons of CO2 equivalent) of 2000 in Hungary to that in India?
Your answer should be compact. 0.01. What is the ratio of the SF6 emissions (in thousand metric tons of CO2 equivalent) of 2005 in Hungary to that in India?
Offer a terse response. 0.01. What is the ratio of the SF6 emissions (in thousand metric tons of CO2 equivalent) of 2008 in Hungary to that in India?
Keep it short and to the point. 0.01. What is the ratio of the SF6 emissions (in thousand metric tons of CO2 equivalent) in 1990 in Hungary to that in Indonesia?
Your response must be concise. 0.02. What is the ratio of the SF6 emissions (in thousand metric tons of CO2 equivalent) in 2000 in Hungary to that in Indonesia?
Provide a succinct answer. 0.03. What is the ratio of the SF6 emissions (in thousand metric tons of CO2 equivalent) in 2005 in Hungary to that in Indonesia?
Make the answer very short. 0.03. What is the ratio of the SF6 emissions (in thousand metric tons of CO2 equivalent) in 2008 in Hungary to that in Indonesia?
Provide a succinct answer. 0.03. What is the ratio of the SF6 emissions (in thousand metric tons of CO2 equivalent) in 1990 in Iceland to that in India?
Offer a very short reply. 0. What is the ratio of the SF6 emissions (in thousand metric tons of CO2 equivalent) in 2000 in Iceland to that in India?
Your answer should be compact. 0.01. What is the ratio of the SF6 emissions (in thousand metric tons of CO2 equivalent) in 2005 in Iceland to that in India?
Provide a short and direct response. 0. What is the ratio of the SF6 emissions (in thousand metric tons of CO2 equivalent) of 2008 in Iceland to that in India?
Offer a terse response. 0. What is the ratio of the SF6 emissions (in thousand metric tons of CO2 equivalent) in 1990 in Iceland to that in Indonesia?
Your answer should be very brief. 0. What is the ratio of the SF6 emissions (in thousand metric tons of CO2 equivalent) of 2000 in Iceland to that in Indonesia?
Give a very brief answer. 0.02. What is the ratio of the SF6 emissions (in thousand metric tons of CO2 equivalent) of 2005 in Iceland to that in Indonesia?
Ensure brevity in your answer.  0. What is the ratio of the SF6 emissions (in thousand metric tons of CO2 equivalent) in 2008 in Iceland to that in Indonesia?
Your answer should be compact. 0. What is the ratio of the SF6 emissions (in thousand metric tons of CO2 equivalent) of 1990 in India to that in Indonesia?
Offer a very short reply. 5.42. What is the ratio of the SF6 emissions (in thousand metric tons of CO2 equivalent) in 2000 in India to that in Indonesia?
Ensure brevity in your answer.  4.15. What is the ratio of the SF6 emissions (in thousand metric tons of CO2 equivalent) in 2005 in India to that in Indonesia?
Make the answer very short. 5.17. What is the ratio of the SF6 emissions (in thousand metric tons of CO2 equivalent) in 2008 in India to that in Indonesia?
Offer a terse response. 5.22. What is the difference between the highest and the second highest SF6 emissions (in thousand metric tons of CO2 equivalent) of 1990?
Your response must be concise. 4694.7. What is the difference between the highest and the second highest SF6 emissions (in thousand metric tons of CO2 equivalent) in 2000?
Offer a terse response. 2607.9. What is the difference between the highest and the second highest SF6 emissions (in thousand metric tons of CO2 equivalent) in 2005?
Make the answer very short. 3692.6. What is the difference between the highest and the second highest SF6 emissions (in thousand metric tons of CO2 equivalent) of 2008?
Offer a terse response. 4285. What is the difference between the highest and the lowest SF6 emissions (in thousand metric tons of CO2 equivalent) of 1990?
Offer a terse response. 5754. What is the difference between the highest and the lowest SF6 emissions (in thousand metric tons of CO2 equivalent) of 2000?
Your answer should be very brief. 3416.8. What is the difference between the highest and the lowest SF6 emissions (in thousand metric tons of CO2 equivalent) of 2005?
Ensure brevity in your answer.  4575.2. What is the difference between the highest and the lowest SF6 emissions (in thousand metric tons of CO2 equivalent) of 2008?
Your response must be concise. 5297.4. 